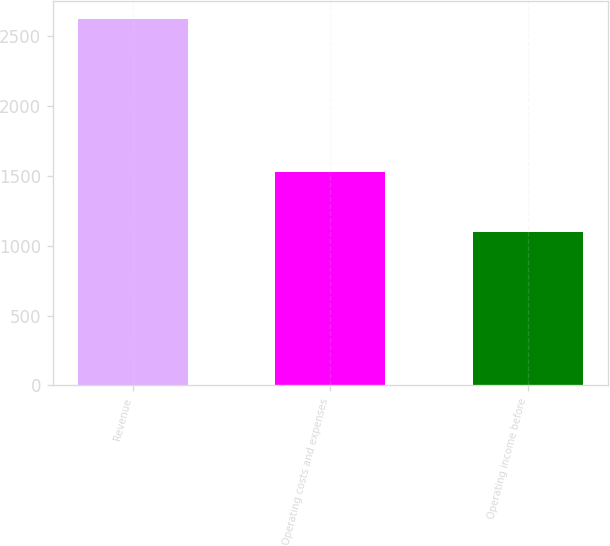Convert chart. <chart><loc_0><loc_0><loc_500><loc_500><bar_chart><fcel>Revenue<fcel>Operating costs and expenses<fcel>Operating income before<nl><fcel>2623<fcel>1527<fcel>1096<nl></chart> 